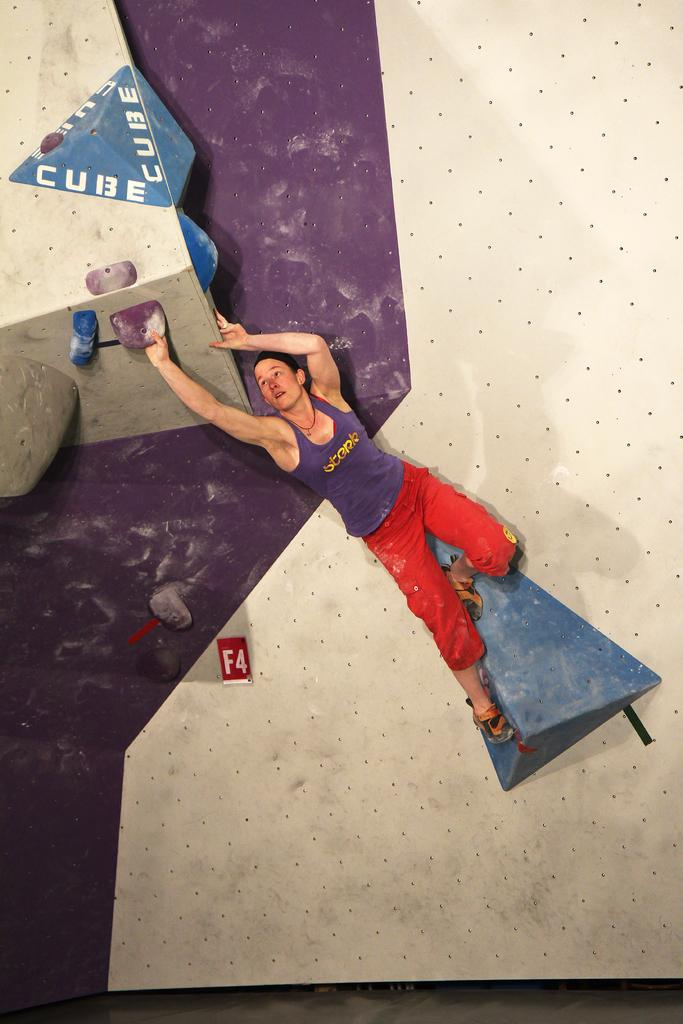What is the position of the person in the image? The person is lying on the floor in the image. What else can be seen on the floor besides the person? There are objects placed on the floor. Can you read any text in the image? Yes, there is text visible on one of the objects. What type of skin is visible on the person's mother in the image? There is no person's mother present in the image, and therefore no skin can be observed. 